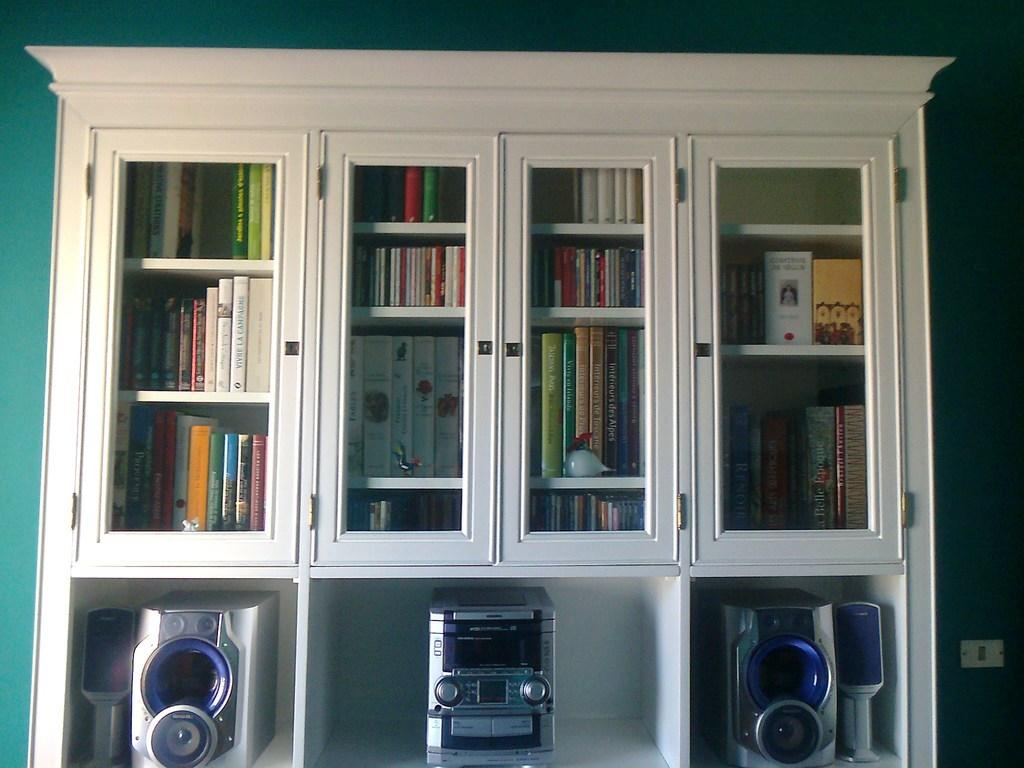<image>
Give a short and clear explanation of the subsequent image. a shelf cabinet with a book in it that says 'belle' on the spine 